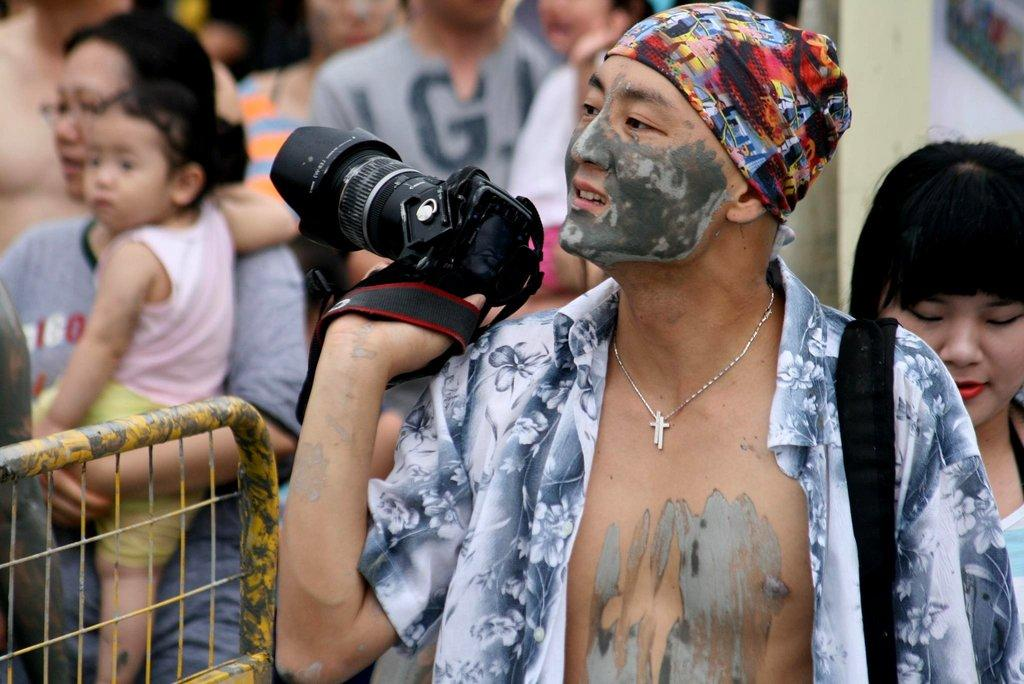How many people are in the image? There is a group of people in the image. What is one person doing in the image? One person is holding a camera. What is another person doing in the image? One person is holding a baby. What can be seen in the background of the image? There is a fence in the image. What type of mouth can be seen on the baby in the image? There is no baby's mouth visible in the image; only the person holding the baby is visible. How far does the fence fall in the image? The fence does not fall in the image; it is stationary. 